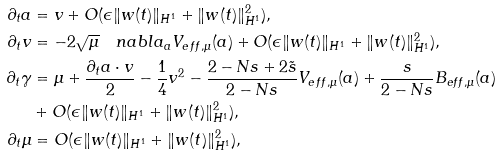<formula> <loc_0><loc_0><loc_500><loc_500>\partial _ { t } a & = v + O ( \epsilon \| w ( t ) \| _ { H ^ { 1 } } + \| w ( t ) \| _ { H ^ { 1 } } ^ { 2 } ) , \\ \partial _ { t } v & = - 2 \sqrt { \mu } \quad n a b l a _ { a } V _ { e f f , \mu } ( a ) + O ( \epsilon \| w ( t ) \| _ { H ^ { 1 } } + \| w ( t ) \| _ { H ^ { 1 } } ^ { 2 } ) , \\ \partial _ { t } \gamma & = \mu + \frac { \partial _ { t } a \cdot v } { 2 } - \frac { 1 } { 4 } v ^ { 2 } - \frac { 2 - N s + 2 \tilde { s } } { 2 - N s } V _ { e f f , \mu } ( a ) + \frac { s } { 2 - N s } B _ { e f f , \mu } ( a ) \\ & + O ( \epsilon \| w ( t ) \| _ { H ^ { 1 } } + \| w ( t ) \| _ { H ^ { 1 } } ^ { 2 } ) , \\ \partial _ { t } { \mu } & = O ( \epsilon \| w ( t ) \| _ { H ^ { 1 } } + \| w ( t ) \| _ { H ^ { 1 } } ^ { 2 } ) ,</formula> 